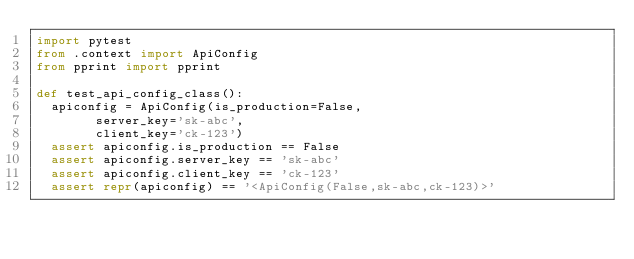<code> <loc_0><loc_0><loc_500><loc_500><_Python_>import pytest
from .context import ApiConfig
from pprint import pprint

def test_api_config_class():
	apiconfig = ApiConfig(is_production=False,
        server_key='sk-abc',
        client_key='ck-123')
	assert apiconfig.is_production == False
	assert apiconfig.server_key == 'sk-abc'
	assert apiconfig.client_key == 'ck-123'
	assert repr(apiconfig) == '<ApiConfig(False,sk-abc,ck-123)>'</code> 